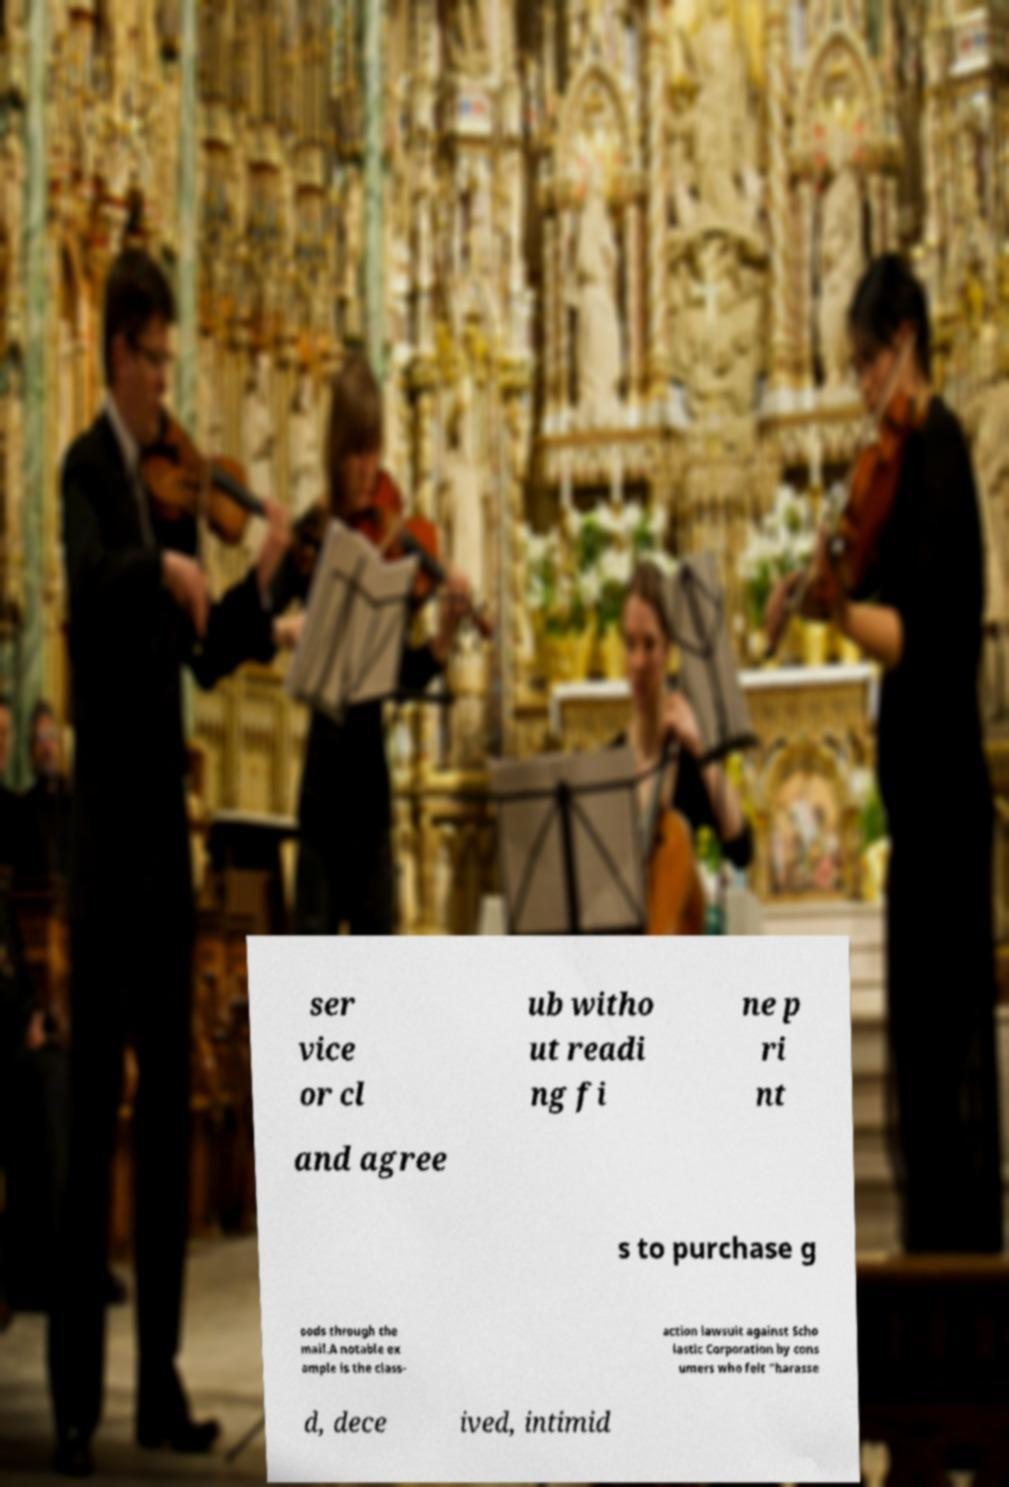Please identify and transcribe the text found in this image. ser vice or cl ub witho ut readi ng fi ne p ri nt and agree s to purchase g oods through the mail.A notable ex ample is the class- action lawsuit against Scho lastic Corporation by cons umers who felt "harasse d, dece ived, intimid 